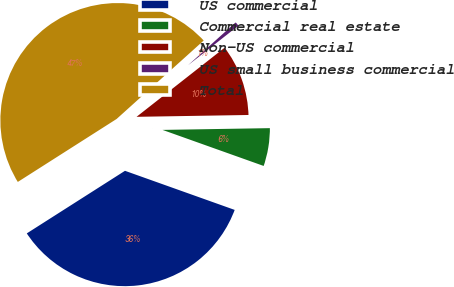Convert chart. <chart><loc_0><loc_0><loc_500><loc_500><pie_chart><fcel>US commercial<fcel>Commercial real estate<fcel>Non-US commercial<fcel>US small business commercial<fcel>Total<nl><fcel>35.52%<fcel>5.71%<fcel>10.33%<fcel>1.08%<fcel>47.36%<nl></chart> 